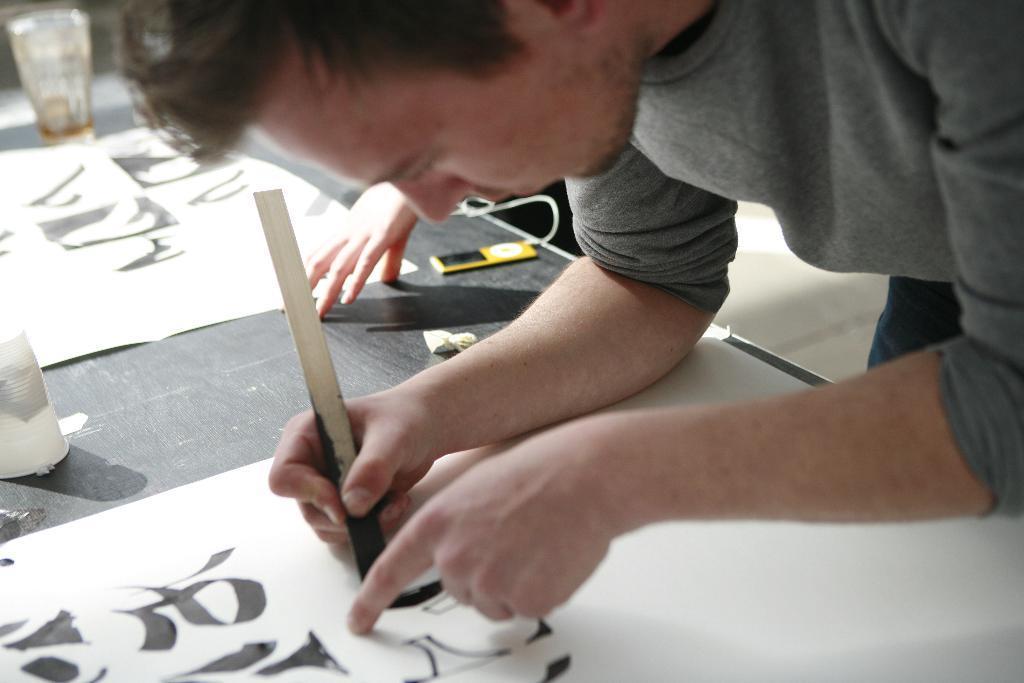Can you describe this image briefly? In this image we can see there is a person standing and holding a stick and at the back we can see the person's hand, in front of them there is a table, on the table there are charts with painting and few objects. 